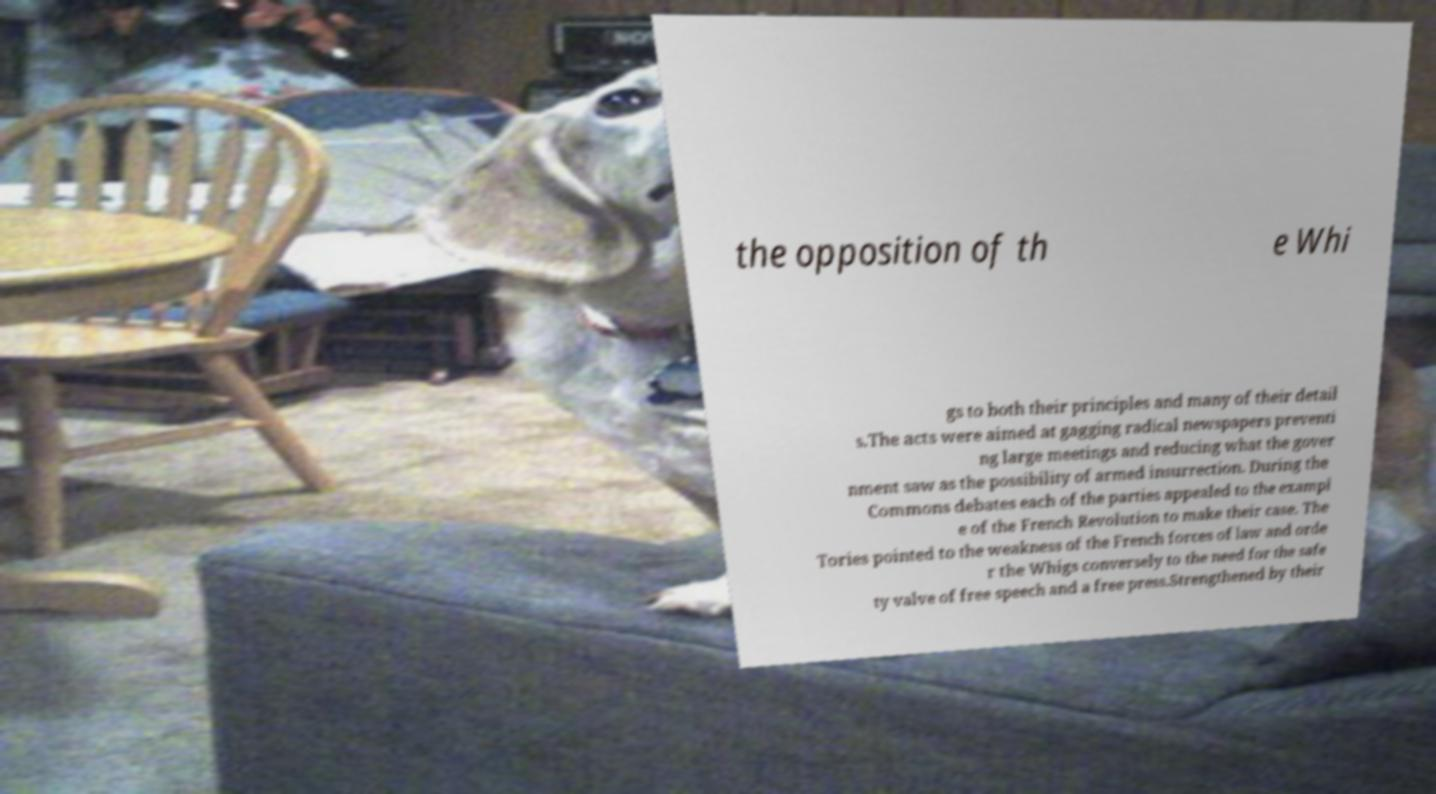Please identify and transcribe the text found in this image. the opposition of th e Whi gs to both their principles and many of their detail s.The acts were aimed at gagging radical newspapers preventi ng large meetings and reducing what the gover nment saw as the possibility of armed insurrection. During the Commons debates each of the parties appealed to the exampl e of the French Revolution to make their case. The Tories pointed to the weakness of the French forces of law and orde r the Whigs conversely to the need for the safe ty valve of free speech and a free press.Strengthened by their 